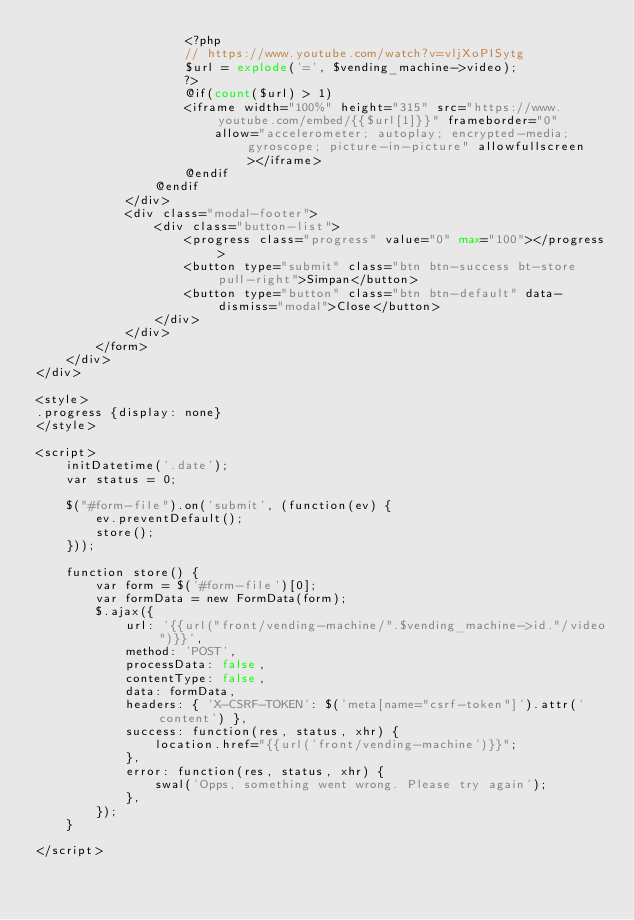Convert code to text. <code><loc_0><loc_0><loc_500><loc_500><_PHP_>                    <?php
                    // https://www.youtube.com/watch?v=vljXoPISytg
                    $url = explode('=', $vending_machine->video);
                    ?>
                    @if(count($url) > 1)
                    <iframe width="100%" height="315" src="https://www.youtube.com/embed/{{$url[1]}}" frameborder="0"
                        allow="accelerometer; autoplay; encrypted-media; gyroscope; picture-in-picture" allowfullscreen></iframe>
                    @endif
                @endif
            </div>
            <div class="modal-footer">
                <div class="button-list">
                    <progress class="progress" value="0" max="100"></progress>
                    <button type="submit" class="btn btn-success bt-store pull-right">Simpan</button>
                    <button type="button" class="btn btn-default" data-dismiss="modal">Close</button>
                </div>
            </div>
        </form>
    </div>
</div>

<style>
.progress {display: none}
</style>

<script>
    initDatetime('.date');
    var status = 0;

    $("#form-file").on('submit', (function(ev) {
        ev.preventDefault();
        store();
    }));

    function store() {
        var form = $('#form-file')[0];
        var formData = new FormData(form);
        $.ajax({
            url: '{{url("front/vending-machine/".$vending_machine->id."/video")}}',
            method: 'POST',
            processData: false,
            contentType: false,
            data: formData,
            headers: { 'X-CSRF-TOKEN': $('meta[name="csrf-token"]').attr('content') },
            success: function(res, status, xhr) {
                location.href="{{url('front/vending-machine')}}";
            },
            error: function(res, status, xhr) {
                swal('Opps, something went wrong. Please try again');
            },
        });
    }

</script></code> 